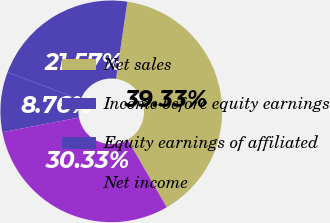<chart> <loc_0><loc_0><loc_500><loc_500><pie_chart><fcel>Net sales<fcel>Income before equity earnings<fcel>Equity earnings of affiliated<fcel>Net income<nl><fcel>39.33%<fcel>21.57%<fcel>8.76%<fcel>30.33%<nl></chart> 